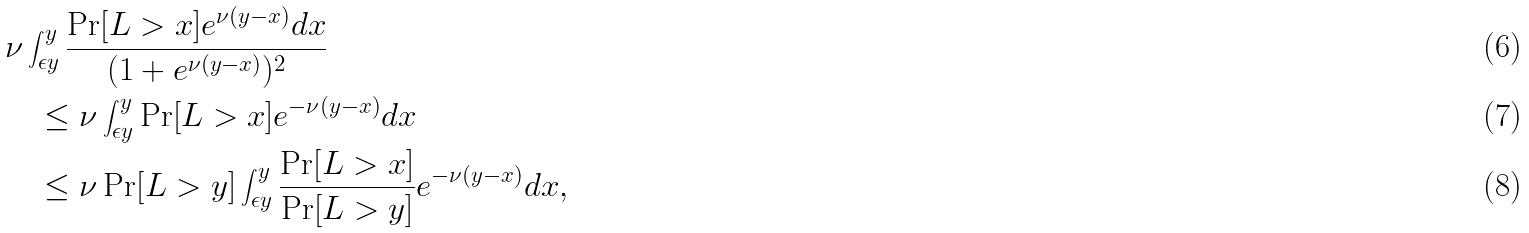Convert formula to latex. <formula><loc_0><loc_0><loc_500><loc_500>& \nu \int _ { \epsilon y } ^ { y } \frac { \Pr [ L > x ] e ^ { \nu ( y - x ) } d x } { ( 1 + e ^ { \nu ( y - x ) } ) ^ { 2 } } \\ & \quad \leq \nu \int _ { \epsilon y } ^ { y } \Pr [ L > x ] e ^ { - \nu ( y - x ) } d x \\ & \quad \leq \nu \Pr [ L > y ] \int _ { \epsilon y } ^ { y } \frac { \Pr [ L > x ] } { \Pr [ L > y ] } e ^ { - \nu ( y - x ) } d x ,</formula> 